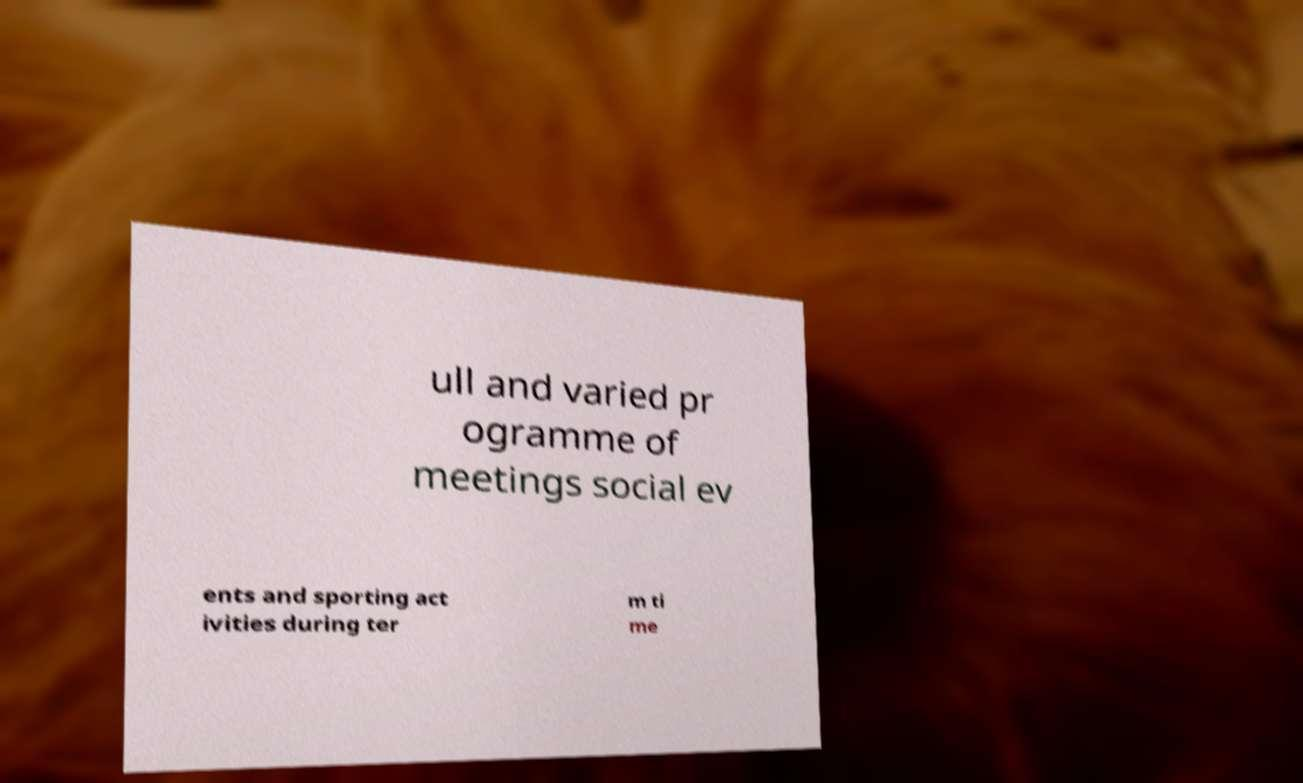Please identify and transcribe the text found in this image. ull and varied pr ogramme of meetings social ev ents and sporting act ivities during ter m ti me 